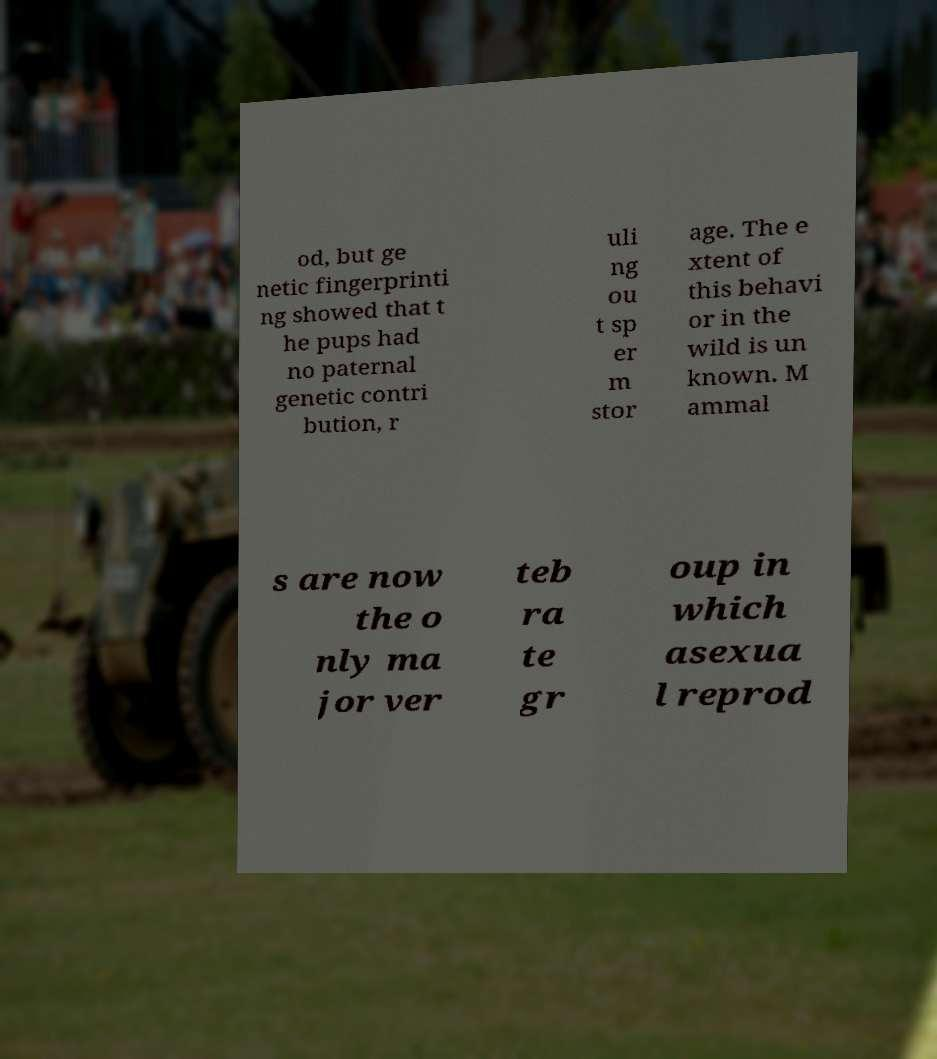Could you extract and type out the text from this image? od, but ge netic fingerprinti ng showed that t he pups had no paternal genetic contri bution, r uli ng ou t sp er m stor age. The e xtent of this behavi or in the wild is un known. M ammal s are now the o nly ma jor ver teb ra te gr oup in which asexua l reprod 